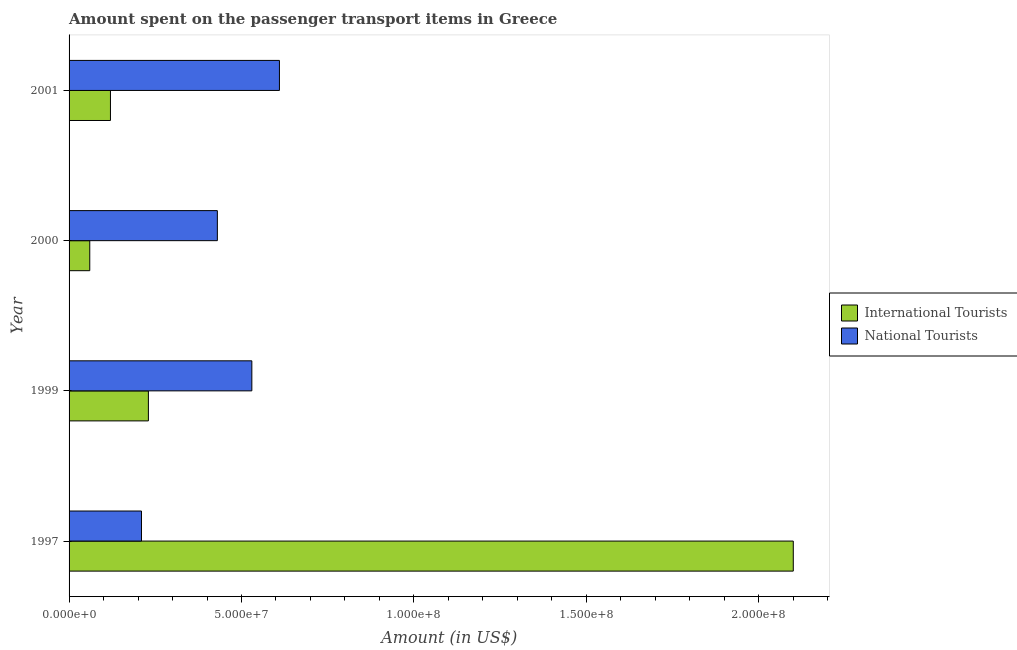How many groups of bars are there?
Ensure brevity in your answer.  4. Are the number of bars on each tick of the Y-axis equal?
Offer a very short reply. Yes. What is the amount spent on transport items of international tourists in 2001?
Give a very brief answer. 1.20e+07. Across all years, what is the maximum amount spent on transport items of international tourists?
Keep it short and to the point. 2.10e+08. Across all years, what is the minimum amount spent on transport items of international tourists?
Provide a short and direct response. 6.00e+06. What is the total amount spent on transport items of international tourists in the graph?
Offer a very short reply. 2.51e+08. What is the difference between the amount spent on transport items of national tourists in 2000 and that in 2001?
Your response must be concise. -1.80e+07. What is the difference between the amount spent on transport items of national tourists in 1997 and the amount spent on transport items of international tourists in 2000?
Your answer should be very brief. 1.50e+07. What is the average amount spent on transport items of national tourists per year?
Your response must be concise. 4.45e+07. In the year 1999, what is the difference between the amount spent on transport items of national tourists and amount spent on transport items of international tourists?
Give a very brief answer. 3.00e+07. What is the ratio of the amount spent on transport items of national tourists in 1997 to that in 2000?
Offer a very short reply. 0.49. Is the difference between the amount spent on transport items of international tourists in 1999 and 2001 greater than the difference between the amount spent on transport items of national tourists in 1999 and 2001?
Give a very brief answer. Yes. What is the difference between the highest and the second highest amount spent on transport items of national tourists?
Give a very brief answer. 8.00e+06. What is the difference between the highest and the lowest amount spent on transport items of international tourists?
Keep it short and to the point. 2.04e+08. Is the sum of the amount spent on transport items of national tourists in 1999 and 2001 greater than the maximum amount spent on transport items of international tourists across all years?
Your response must be concise. No. What does the 1st bar from the top in 1999 represents?
Your answer should be compact. National Tourists. What does the 1st bar from the bottom in 1999 represents?
Give a very brief answer. International Tourists. How many bars are there?
Provide a short and direct response. 8. How many years are there in the graph?
Make the answer very short. 4. What is the difference between two consecutive major ticks on the X-axis?
Provide a succinct answer. 5.00e+07. Does the graph contain grids?
Provide a short and direct response. No. What is the title of the graph?
Your answer should be very brief. Amount spent on the passenger transport items in Greece. What is the label or title of the Y-axis?
Offer a terse response. Year. What is the Amount (in US$) of International Tourists in 1997?
Keep it short and to the point. 2.10e+08. What is the Amount (in US$) of National Tourists in 1997?
Ensure brevity in your answer.  2.10e+07. What is the Amount (in US$) of International Tourists in 1999?
Give a very brief answer. 2.30e+07. What is the Amount (in US$) of National Tourists in 1999?
Your answer should be compact. 5.30e+07. What is the Amount (in US$) of National Tourists in 2000?
Your response must be concise. 4.30e+07. What is the Amount (in US$) in International Tourists in 2001?
Make the answer very short. 1.20e+07. What is the Amount (in US$) of National Tourists in 2001?
Ensure brevity in your answer.  6.10e+07. Across all years, what is the maximum Amount (in US$) of International Tourists?
Offer a terse response. 2.10e+08. Across all years, what is the maximum Amount (in US$) of National Tourists?
Your answer should be very brief. 6.10e+07. Across all years, what is the minimum Amount (in US$) of International Tourists?
Your answer should be very brief. 6.00e+06. Across all years, what is the minimum Amount (in US$) of National Tourists?
Keep it short and to the point. 2.10e+07. What is the total Amount (in US$) of International Tourists in the graph?
Make the answer very short. 2.51e+08. What is the total Amount (in US$) of National Tourists in the graph?
Provide a succinct answer. 1.78e+08. What is the difference between the Amount (in US$) of International Tourists in 1997 and that in 1999?
Give a very brief answer. 1.87e+08. What is the difference between the Amount (in US$) in National Tourists in 1997 and that in 1999?
Your response must be concise. -3.20e+07. What is the difference between the Amount (in US$) in International Tourists in 1997 and that in 2000?
Provide a short and direct response. 2.04e+08. What is the difference between the Amount (in US$) of National Tourists in 1997 and that in 2000?
Provide a short and direct response. -2.20e+07. What is the difference between the Amount (in US$) in International Tourists in 1997 and that in 2001?
Offer a terse response. 1.98e+08. What is the difference between the Amount (in US$) in National Tourists in 1997 and that in 2001?
Your answer should be compact. -4.00e+07. What is the difference between the Amount (in US$) of International Tourists in 1999 and that in 2000?
Your answer should be compact. 1.70e+07. What is the difference between the Amount (in US$) of National Tourists in 1999 and that in 2000?
Offer a very short reply. 1.00e+07. What is the difference between the Amount (in US$) in International Tourists in 1999 and that in 2001?
Keep it short and to the point. 1.10e+07. What is the difference between the Amount (in US$) of National Tourists in 1999 and that in 2001?
Your answer should be very brief. -8.00e+06. What is the difference between the Amount (in US$) in International Tourists in 2000 and that in 2001?
Provide a short and direct response. -6.00e+06. What is the difference between the Amount (in US$) of National Tourists in 2000 and that in 2001?
Offer a terse response. -1.80e+07. What is the difference between the Amount (in US$) in International Tourists in 1997 and the Amount (in US$) in National Tourists in 1999?
Ensure brevity in your answer.  1.57e+08. What is the difference between the Amount (in US$) in International Tourists in 1997 and the Amount (in US$) in National Tourists in 2000?
Your response must be concise. 1.67e+08. What is the difference between the Amount (in US$) of International Tourists in 1997 and the Amount (in US$) of National Tourists in 2001?
Give a very brief answer. 1.49e+08. What is the difference between the Amount (in US$) in International Tourists in 1999 and the Amount (in US$) in National Tourists in 2000?
Ensure brevity in your answer.  -2.00e+07. What is the difference between the Amount (in US$) in International Tourists in 1999 and the Amount (in US$) in National Tourists in 2001?
Keep it short and to the point. -3.80e+07. What is the difference between the Amount (in US$) in International Tourists in 2000 and the Amount (in US$) in National Tourists in 2001?
Provide a short and direct response. -5.50e+07. What is the average Amount (in US$) of International Tourists per year?
Offer a very short reply. 6.28e+07. What is the average Amount (in US$) in National Tourists per year?
Offer a very short reply. 4.45e+07. In the year 1997, what is the difference between the Amount (in US$) of International Tourists and Amount (in US$) of National Tourists?
Provide a succinct answer. 1.89e+08. In the year 1999, what is the difference between the Amount (in US$) of International Tourists and Amount (in US$) of National Tourists?
Give a very brief answer. -3.00e+07. In the year 2000, what is the difference between the Amount (in US$) of International Tourists and Amount (in US$) of National Tourists?
Your answer should be compact. -3.70e+07. In the year 2001, what is the difference between the Amount (in US$) of International Tourists and Amount (in US$) of National Tourists?
Your answer should be very brief. -4.90e+07. What is the ratio of the Amount (in US$) in International Tourists in 1997 to that in 1999?
Give a very brief answer. 9.13. What is the ratio of the Amount (in US$) in National Tourists in 1997 to that in 1999?
Provide a succinct answer. 0.4. What is the ratio of the Amount (in US$) of International Tourists in 1997 to that in 2000?
Make the answer very short. 35. What is the ratio of the Amount (in US$) in National Tourists in 1997 to that in 2000?
Ensure brevity in your answer.  0.49. What is the ratio of the Amount (in US$) of International Tourists in 1997 to that in 2001?
Keep it short and to the point. 17.5. What is the ratio of the Amount (in US$) of National Tourists in 1997 to that in 2001?
Your answer should be compact. 0.34. What is the ratio of the Amount (in US$) in International Tourists in 1999 to that in 2000?
Your response must be concise. 3.83. What is the ratio of the Amount (in US$) in National Tourists in 1999 to that in 2000?
Keep it short and to the point. 1.23. What is the ratio of the Amount (in US$) of International Tourists in 1999 to that in 2001?
Make the answer very short. 1.92. What is the ratio of the Amount (in US$) of National Tourists in 1999 to that in 2001?
Your response must be concise. 0.87. What is the ratio of the Amount (in US$) of International Tourists in 2000 to that in 2001?
Ensure brevity in your answer.  0.5. What is the ratio of the Amount (in US$) of National Tourists in 2000 to that in 2001?
Your answer should be compact. 0.7. What is the difference between the highest and the second highest Amount (in US$) in International Tourists?
Ensure brevity in your answer.  1.87e+08. What is the difference between the highest and the lowest Amount (in US$) of International Tourists?
Your answer should be compact. 2.04e+08. What is the difference between the highest and the lowest Amount (in US$) in National Tourists?
Provide a succinct answer. 4.00e+07. 